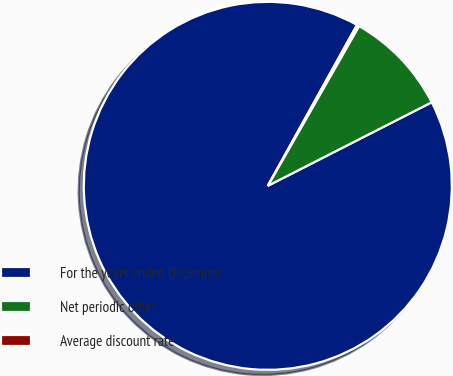<chart> <loc_0><loc_0><loc_500><loc_500><pie_chart><fcel>For the years ended December<fcel>Net periodic other<fcel>Average discount rate<nl><fcel>90.56%<fcel>9.24%<fcel>0.2%<nl></chart> 